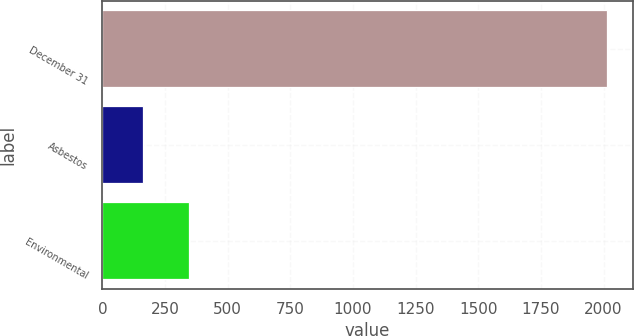Convert chart to OTSL. <chart><loc_0><loc_0><loc_500><loc_500><bar_chart><fcel>December 31<fcel>Asbestos<fcel>Environmental<nl><fcel>2015<fcel>162<fcel>347.3<nl></chart> 